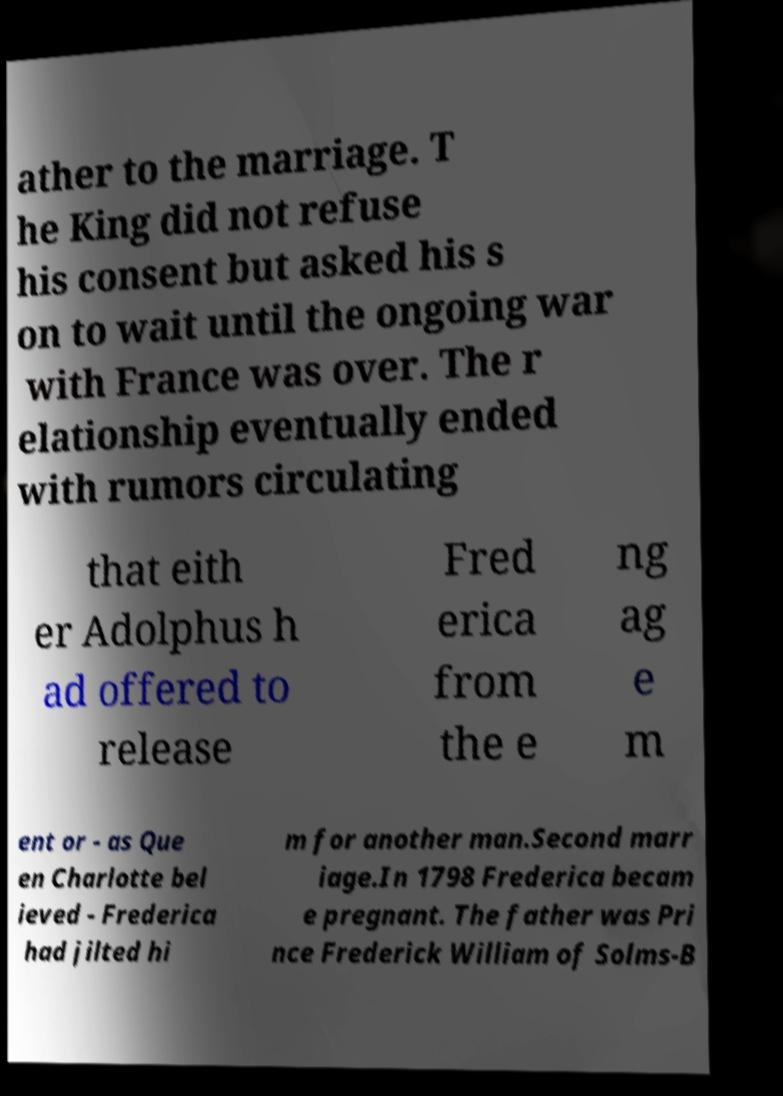Please identify and transcribe the text found in this image. ather to the marriage. T he King did not refuse his consent but asked his s on to wait until the ongoing war with France was over. The r elationship eventually ended with rumors circulating that eith er Adolphus h ad offered to release Fred erica from the e ng ag e m ent or - as Que en Charlotte bel ieved - Frederica had jilted hi m for another man.Second marr iage.In 1798 Frederica becam e pregnant. The father was Pri nce Frederick William of Solms-B 